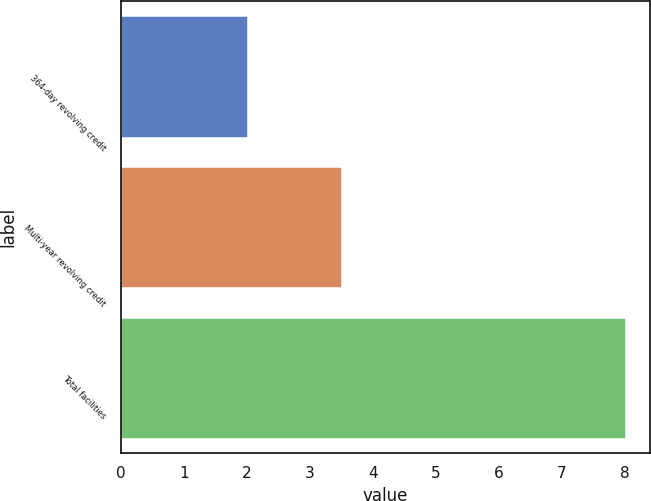<chart> <loc_0><loc_0><loc_500><loc_500><bar_chart><fcel>364-day revolving credit<fcel>Multi-year revolving credit<fcel>Total facilities<nl><fcel>2<fcel>3.5<fcel>8<nl></chart> 